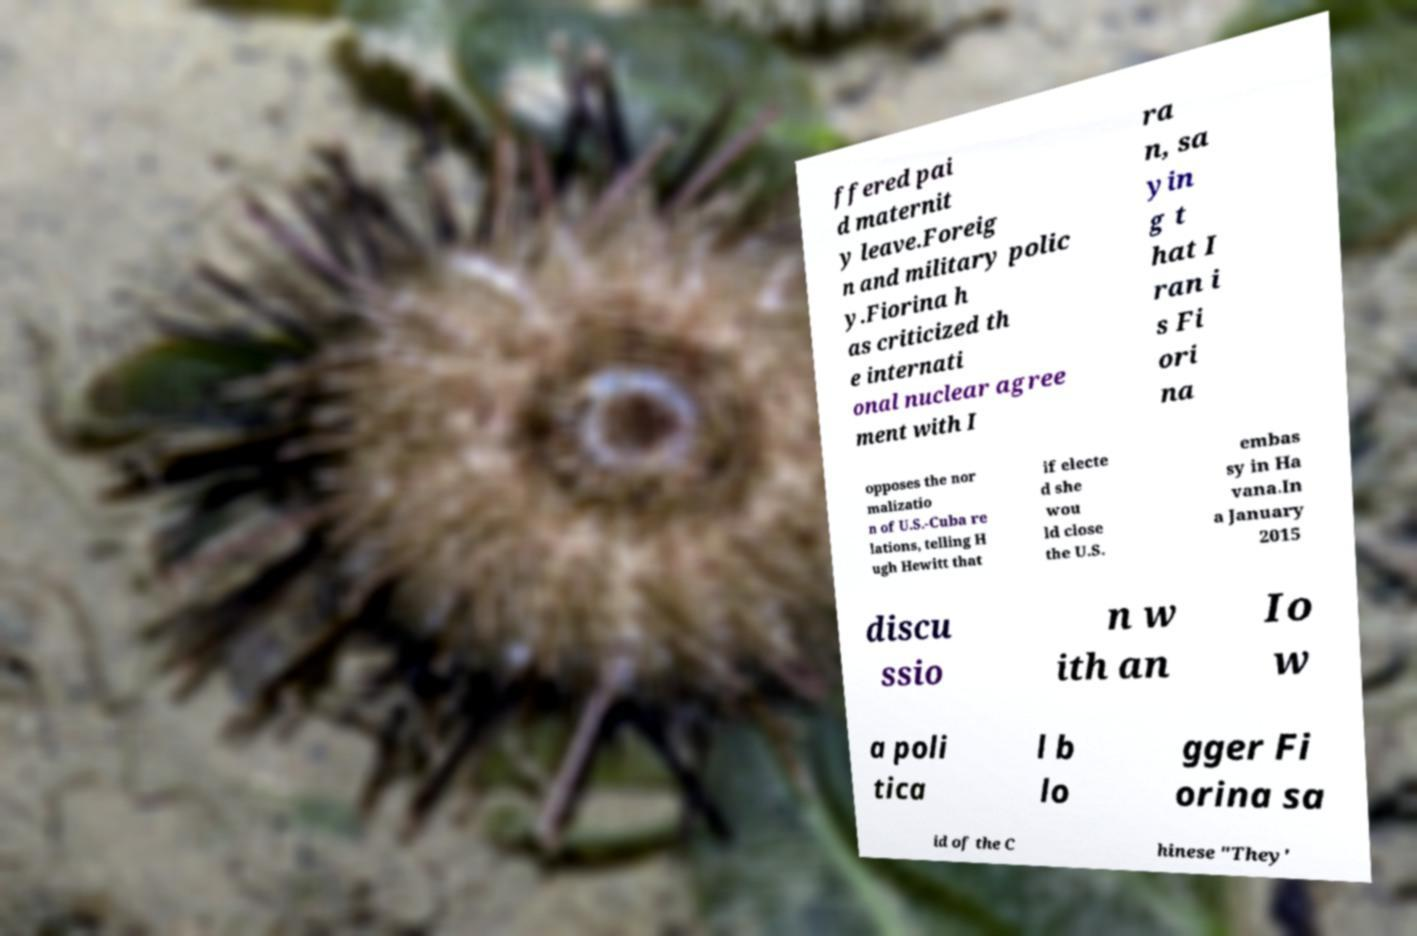Please identify and transcribe the text found in this image. ffered pai d maternit y leave.Foreig n and military polic y.Fiorina h as criticized th e internati onal nuclear agree ment with I ra n, sa yin g t hat I ran i s Fi ori na opposes the nor malizatio n of U.S.-Cuba re lations, telling H ugh Hewitt that if electe d she wou ld close the U.S. embas sy in Ha vana.In a January 2015 discu ssio n w ith an Io w a poli tica l b lo gger Fi orina sa id of the C hinese "They' 